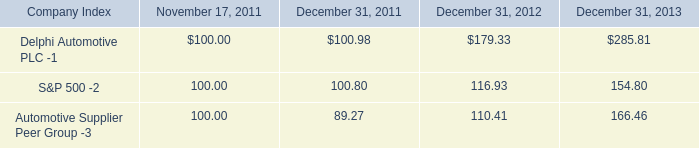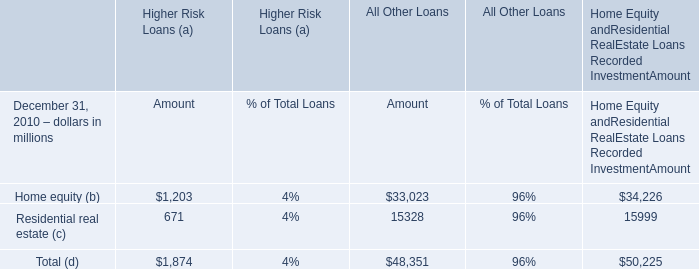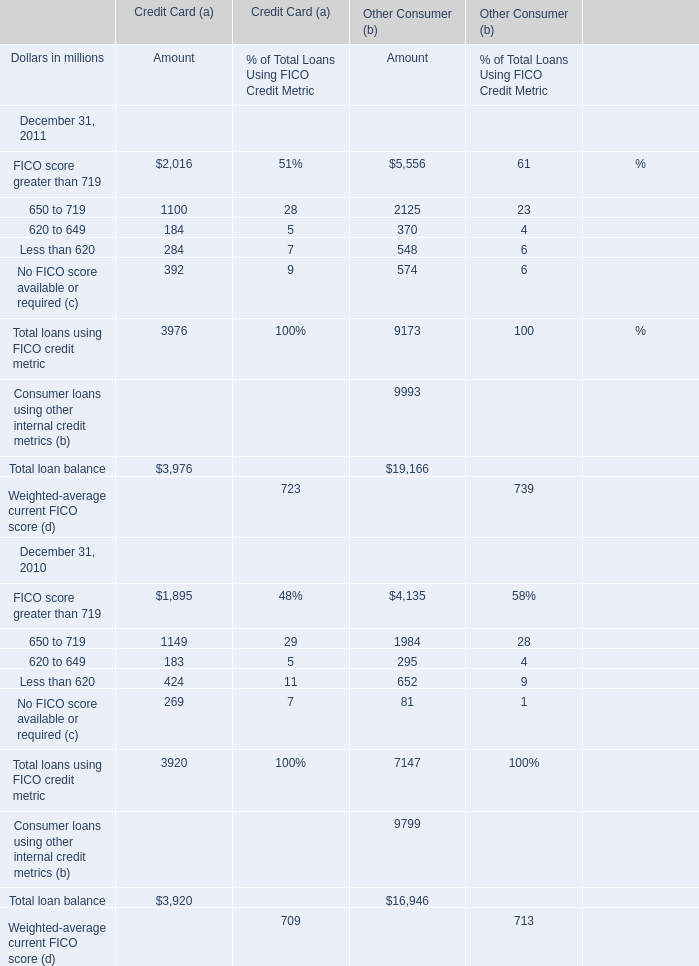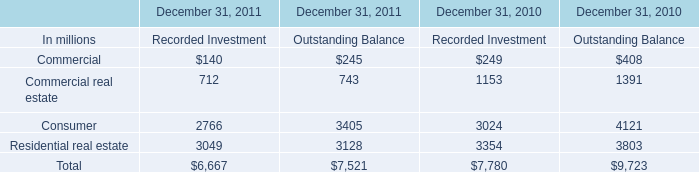Which element exceeds 20 % of total for Higher Risk Loans (a) of Amout in 2010? 
Answer: Home equity (b), Residential real estate (c). 